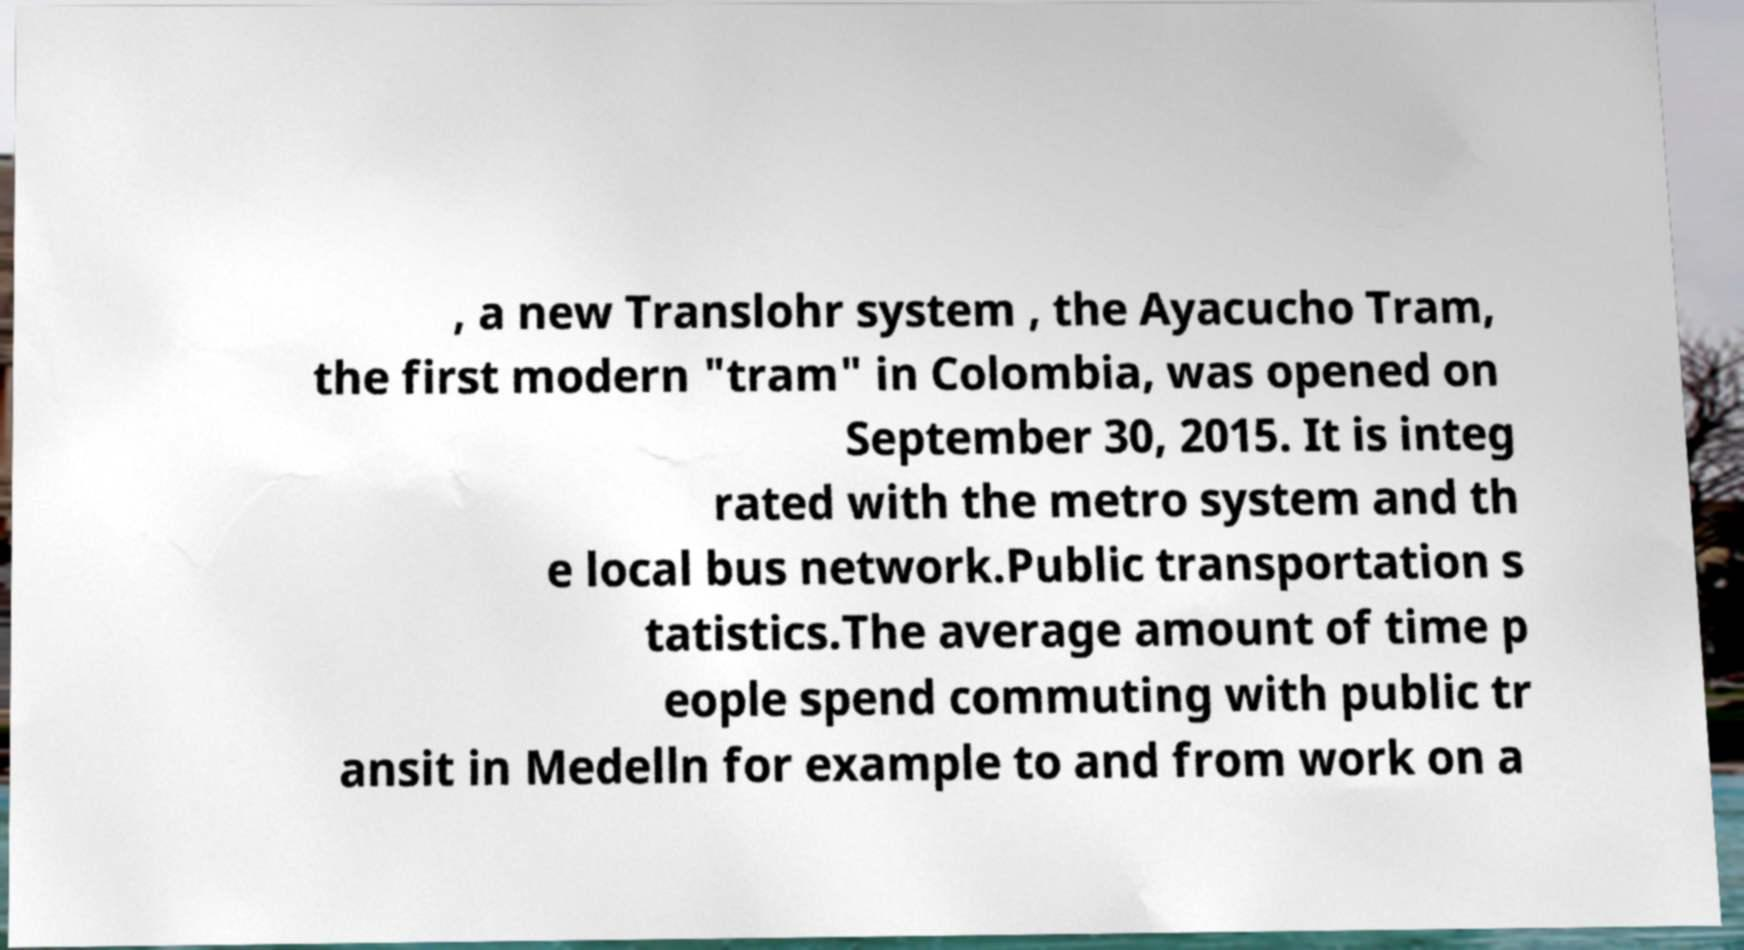Could you assist in decoding the text presented in this image and type it out clearly? , a new Translohr system , the Ayacucho Tram, the first modern "tram" in Colombia, was opened on September 30, 2015. It is integ rated with the metro system and th e local bus network.Public transportation s tatistics.The average amount of time p eople spend commuting with public tr ansit in Medelln for example to and from work on a 